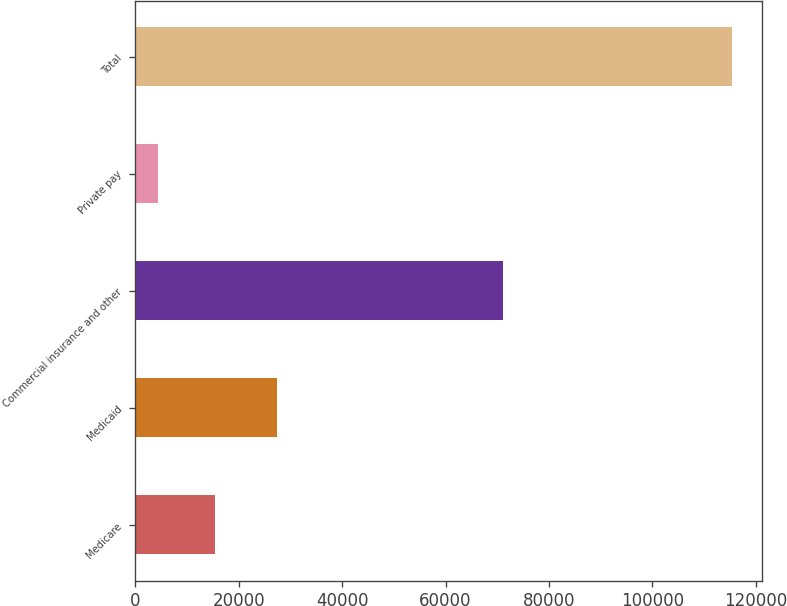Convert chart. <chart><loc_0><loc_0><loc_500><loc_500><bar_chart><fcel>Medicare<fcel>Medicaid<fcel>Commercial insurance and other<fcel>Private pay<fcel>Total<nl><fcel>15465.3<fcel>27422<fcel>71191<fcel>4354<fcel>115467<nl></chart> 